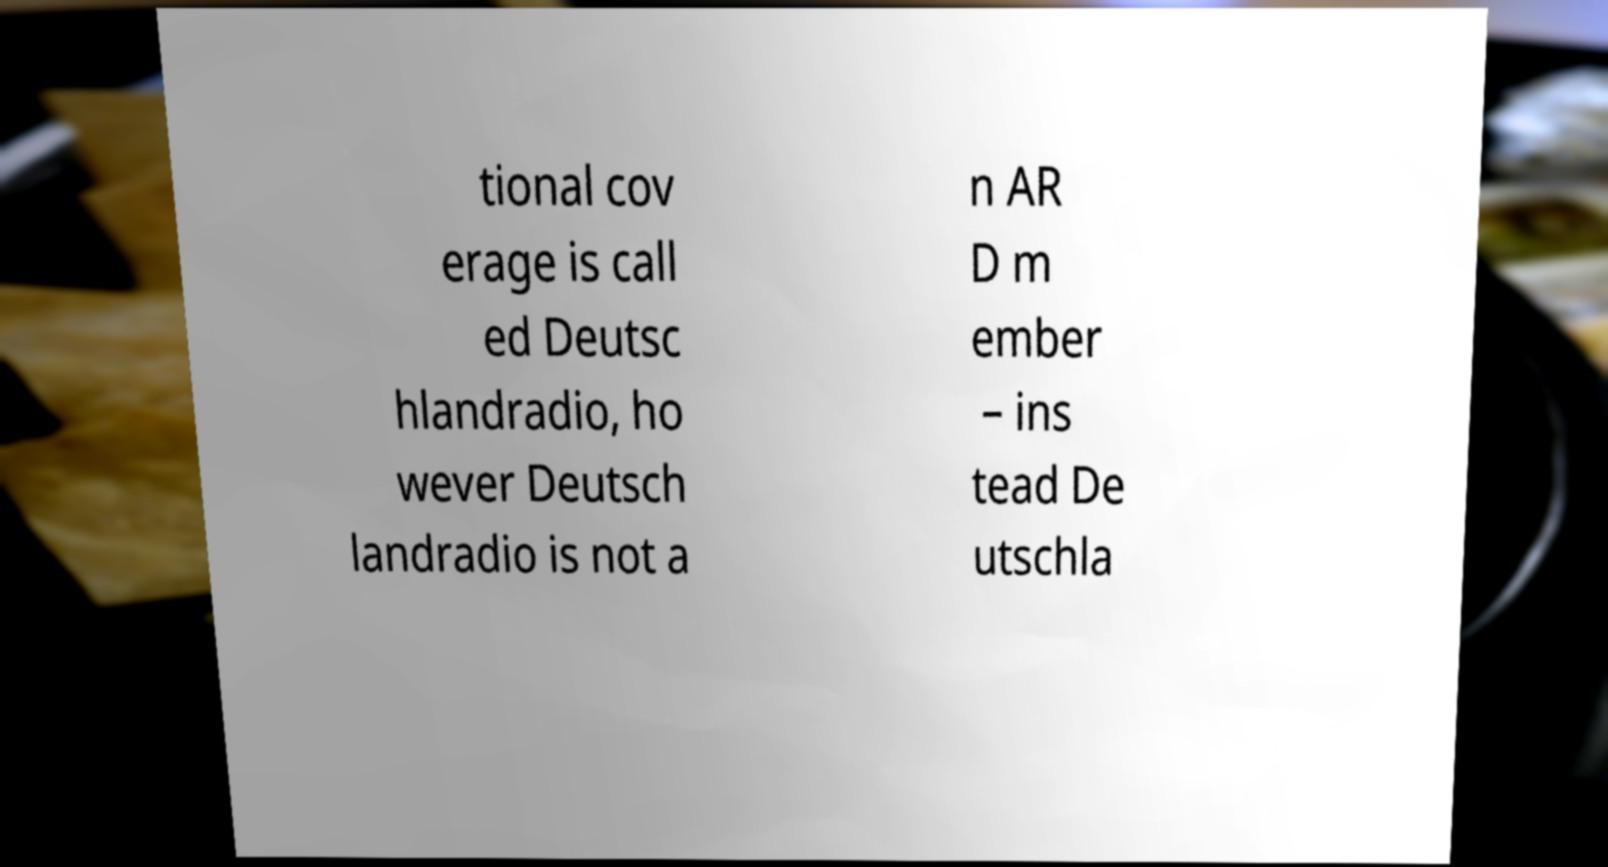For documentation purposes, I need the text within this image transcribed. Could you provide that? tional cov erage is call ed Deutsc hlandradio, ho wever Deutsch landradio is not a n AR D m ember – ins tead De utschla 